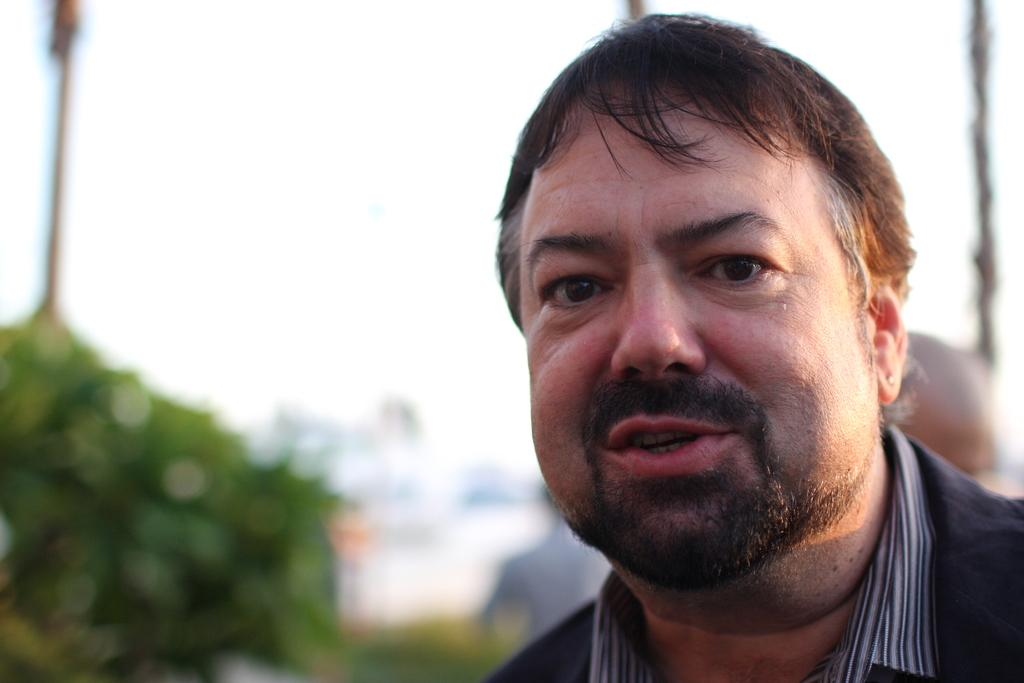Who is present in the image? There is a man in the image. What is the man wearing? The man is wearing clothes. What can be seen in the image besides the man? There are plants and the sky visible in the image. How would you describe the background of the image? The background of the image is blurred. What type of music can be heard playing in the background of the image? There is no music present in the image, as it is a still photograph. Can you tell me how many coaches are visible in the image? There are no coaches present in the image. 